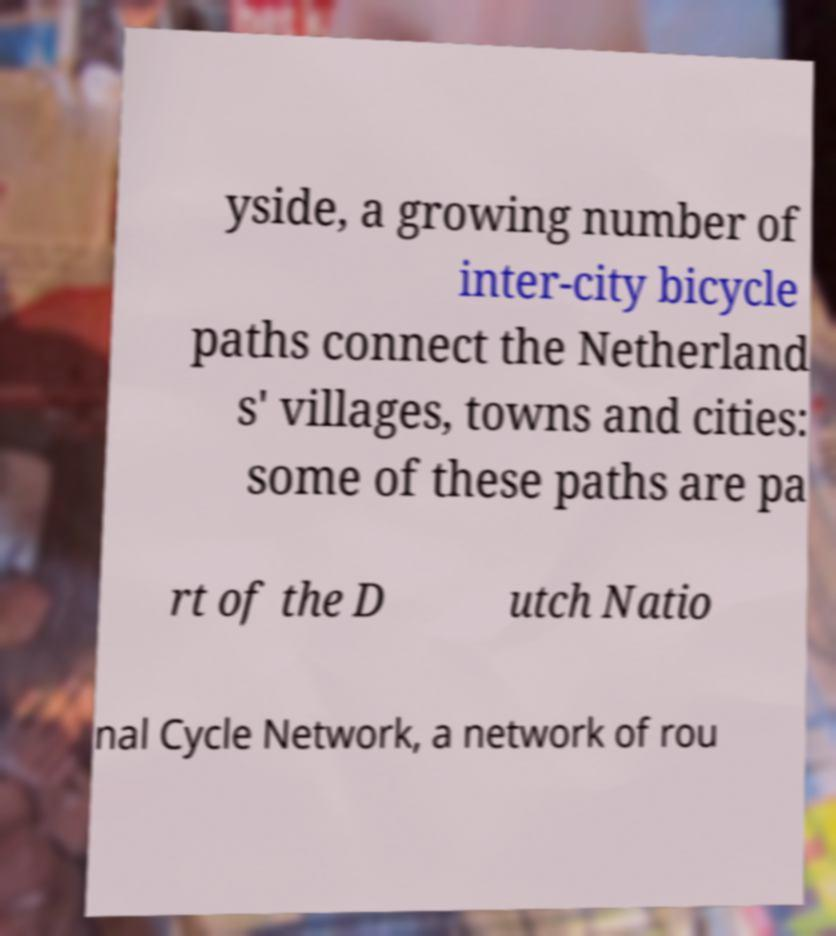Can you read and provide the text displayed in the image?This photo seems to have some interesting text. Can you extract and type it out for me? yside, a growing number of inter-city bicycle paths connect the Netherland s' villages, towns and cities: some of these paths are pa rt of the D utch Natio nal Cycle Network, a network of rou 